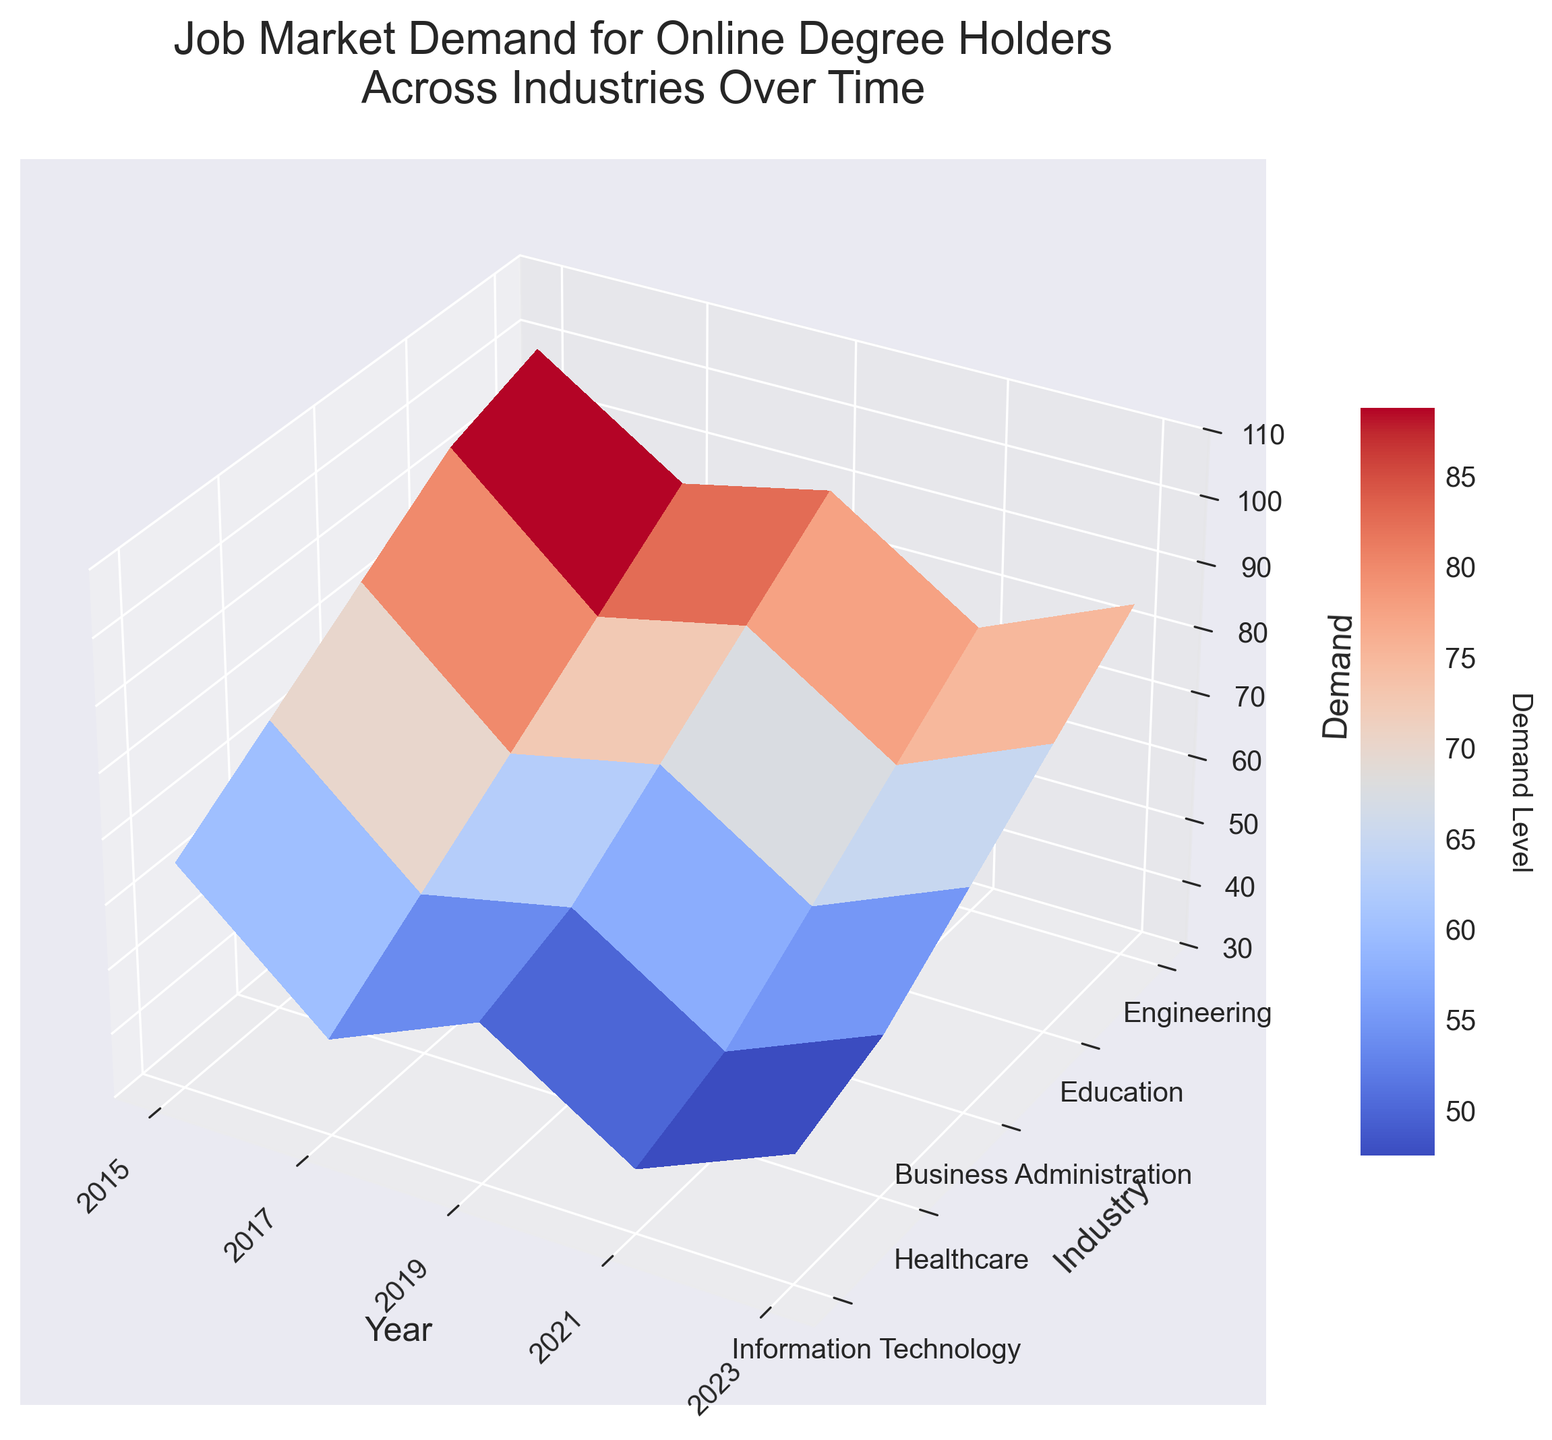What is the title of the plot? The title of the plot is displayed at the top, indicating what the plot is about.
Answer: Job Market Demand for Online Degree Holders Across Industries Over Time What are the labels for the x-axis, y-axis, and z-axis? The labels for the axes are typically found along or near the respective axes within the plot.
Answer: Year (x-axis), Industry (y-axis), Demand (z-axis) In which year did Information Technology see the highest demand? By observing the peaks of the surface in the Information Technology row, the highest point corresponds to the year 2023.
Answer: 2023 How does the demand for Healthcare in 2019 compare to that in 2023? By comparing the height of the surface at the Healthcare row and columns corresponding to 2019 and 2023, the demand in 2023 is higher.
Answer: 2023 has higher demand What is the trend in demand for Education from 2015 to 2023? Observing the progression of the surface along the Education row from 2015 to 2023 shows an increasing trend.
Answer: Increasing Which industry saw the most consistent increase in demand over the years? By looking at the smoothness and slope of the surface across rows, Information Technology shows the most consistent and steep increase.
Answer: Information Technology How did the demand for Business Administration change from 2017 to 2021? Observing the demand values in the Business Administration row for 2017 and 2021, it shows an increase from 60 to 80.
Answer: Increased by 20 points Between 2019 and 2023, which industry experienced the largest increase in demand? Calculating the difference in demand between 2019 and 2023 for each industry, Information Technology shows the largest increase from 85 to 100.
Answer: Information Technology What's the difference in demand between Engineering and Education in 2021? Comparing the heights of the surface at the Engineering and Education rows for 2021, the difference is 75 - 65 = 10.
Answer: 10 Which industry had the lowest demand in 2015? Observing the lowest point on the surface for the year 2015, Education had the demand of 40, which is the lowest.
Answer: Education 